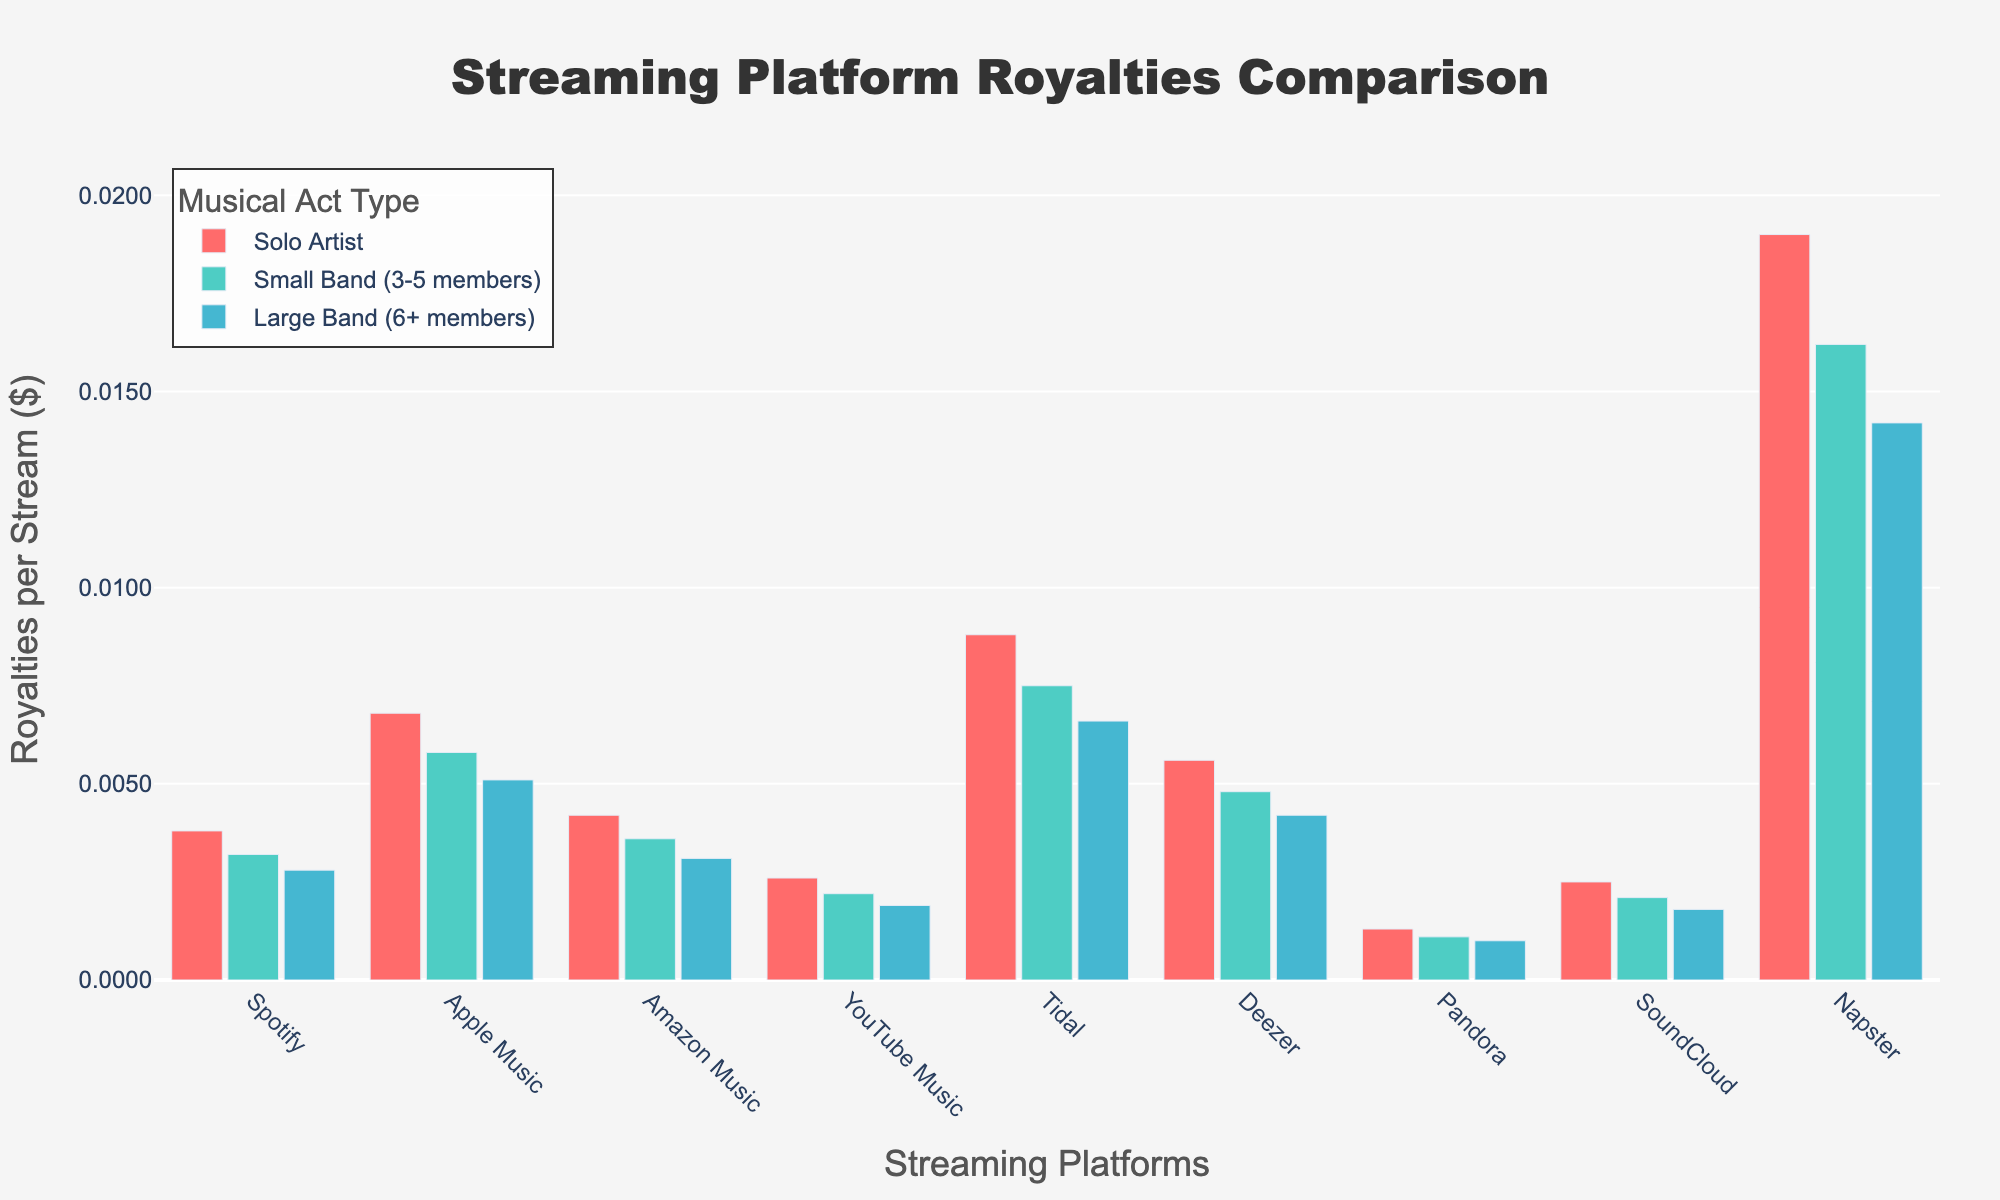what platform offers the highest royalties for a solo artist? Looking at the bar for solo artists across all platforms, the tallest bar is for Napster. Therefore, Napster offers the highest royalties for a solo artist.
Answer: Napster which platform provides the least royalties for a large band (6+ members)? By observing the bars representing large bands (6+ members), the shortest bar belongs to Pandora. This means Pandora provides the least royalties for large bands.
Answer: Pandora what is the difference in royalties for solo artists between Tidal and Spotify? The bar for Tidal (solo artist) shows a value of 0.0088, and for Spotify, it shows 0.0038. Subtracting these values gives 0.0088 - 0.0038 = 0.0050.
Answer: 0.0050 how much more does Amazon Music pay to solo artists than to large bands? The bar for Amazon Music (solo artist) shows 0.0042, and for large bands, it shows 0.0031. Subtracting these values: 0.0042 - 0.0031 = 0.0011.
Answer: 0.0011 which platform has the smallest difference in royalties between solo artists and small bands? The smallest gap between the bars for solo artists and small bands is observed for Pandora. The height difference for solo artist (0.0013) and small band (0.0011) is 0.0002, the smallest among all platforms.
Answer: Pandora rank the platforms from highest to lowest royalties for small bands (3-5 members). Comparing the heights of the bars representing small bands for each platform: Napster, Tidal, Apple Music, Deezer, Amazon Music, Spotify, SoundCloud, YouTube Music, Pandora, the order is Napster > Tidal > Apple Music > Deezer > Amazon Music > Spotify > SoundCloud > YouTube Music > Pandora.
Answer: Napster, Tidal, Apple Music, Deezer, Amazon Music, Spotify, SoundCloud, YouTube Music, Pandora which platform has the highest variation in royalties payments across different types of musical acts? By visually comparing the differences (height ranges) among the bars within each platform grouping, Napster shows the greatest height difference between solo artists, small bands, and large bands. This indicates the highest variation in royalties payments.
Answer: Napster how do the royalties for a small band on Apple Music compare to those on Spotify? The bar for small bands on Apple Music is higher than on Spotify. Apple Music pays 0.0058 whereas Spotify pays 0.0032. Therefore, Apple Music pays more royalties to small bands.
Answer: Apple Music pays more how does Tidal’s payment to large bands compare to Amazon Music’s payment to small bands? Looking at the bars for Tidal (large bands) and Amazon Music (small bands), Tidal pays 0.0066 and Amazon Music pays 0.0036. Tidal’s payment is greater.
Answer: Tidal pays more 